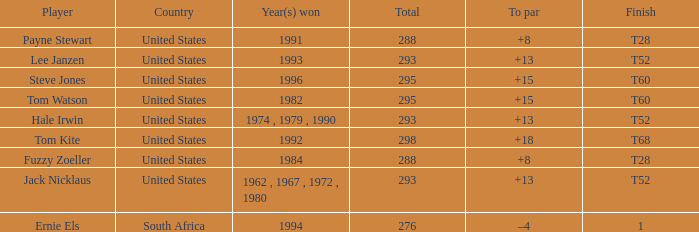What year did player steve jones, who had a t60 finish, win? 1996.0. 